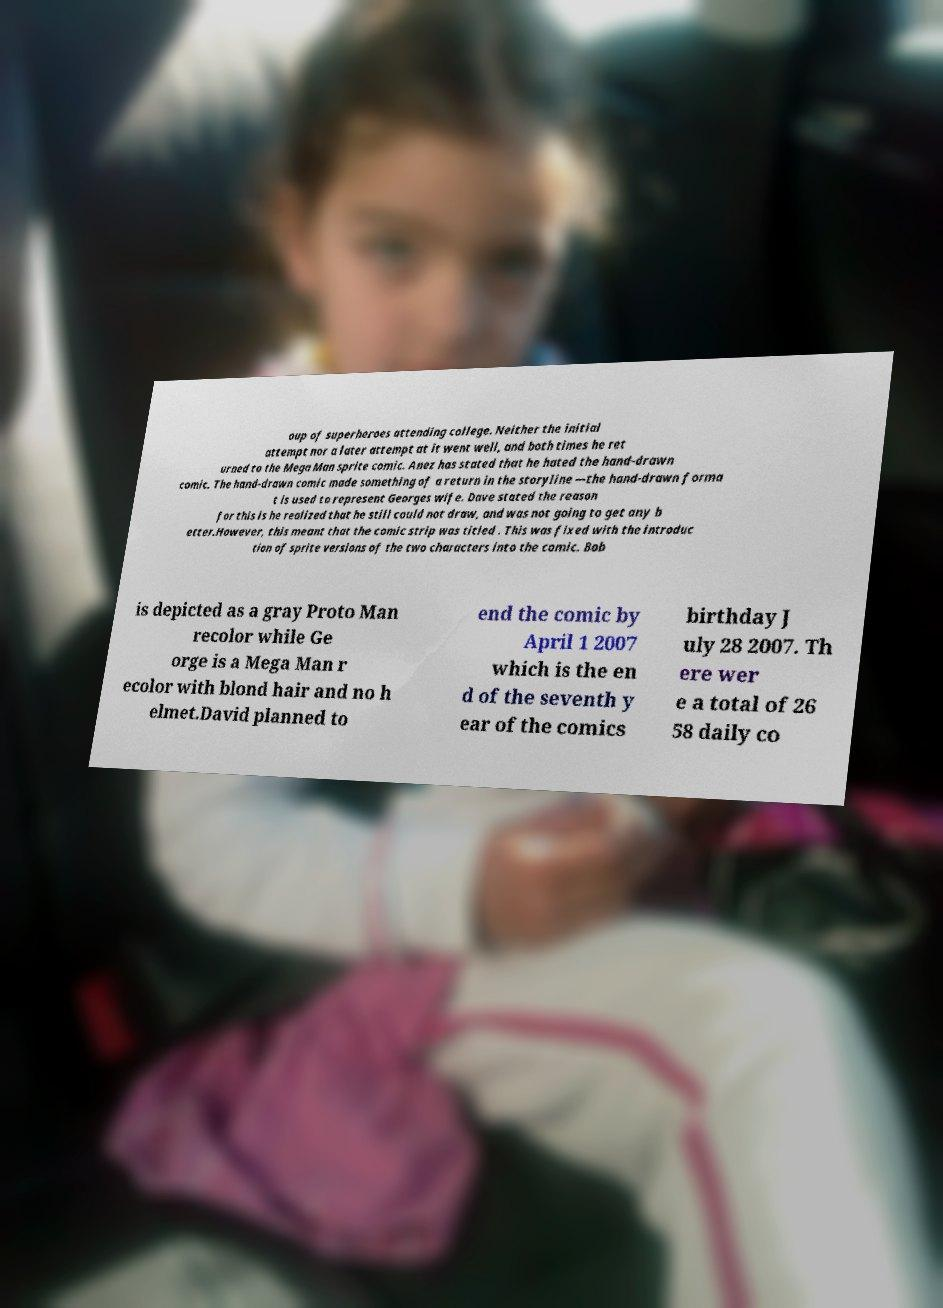There's text embedded in this image that I need extracted. Can you transcribe it verbatim? oup of superheroes attending college. Neither the initial attempt nor a later attempt at it went well, and both times he ret urned to the Mega Man sprite comic. Anez has stated that he hated the hand-drawn comic. The hand-drawn comic made something of a return in the storyline —the hand-drawn forma t is used to represent Georges wife. Dave stated the reason for this is he realized that he still could not draw, and was not going to get any b etter.However, this meant that the comic strip was titled . This was fixed with the introduc tion of sprite versions of the two characters into the comic. Bob is depicted as a gray Proto Man recolor while Ge orge is a Mega Man r ecolor with blond hair and no h elmet.David planned to end the comic by April 1 2007 which is the en d of the seventh y ear of the comics birthday J uly 28 2007. Th ere wer e a total of 26 58 daily co 